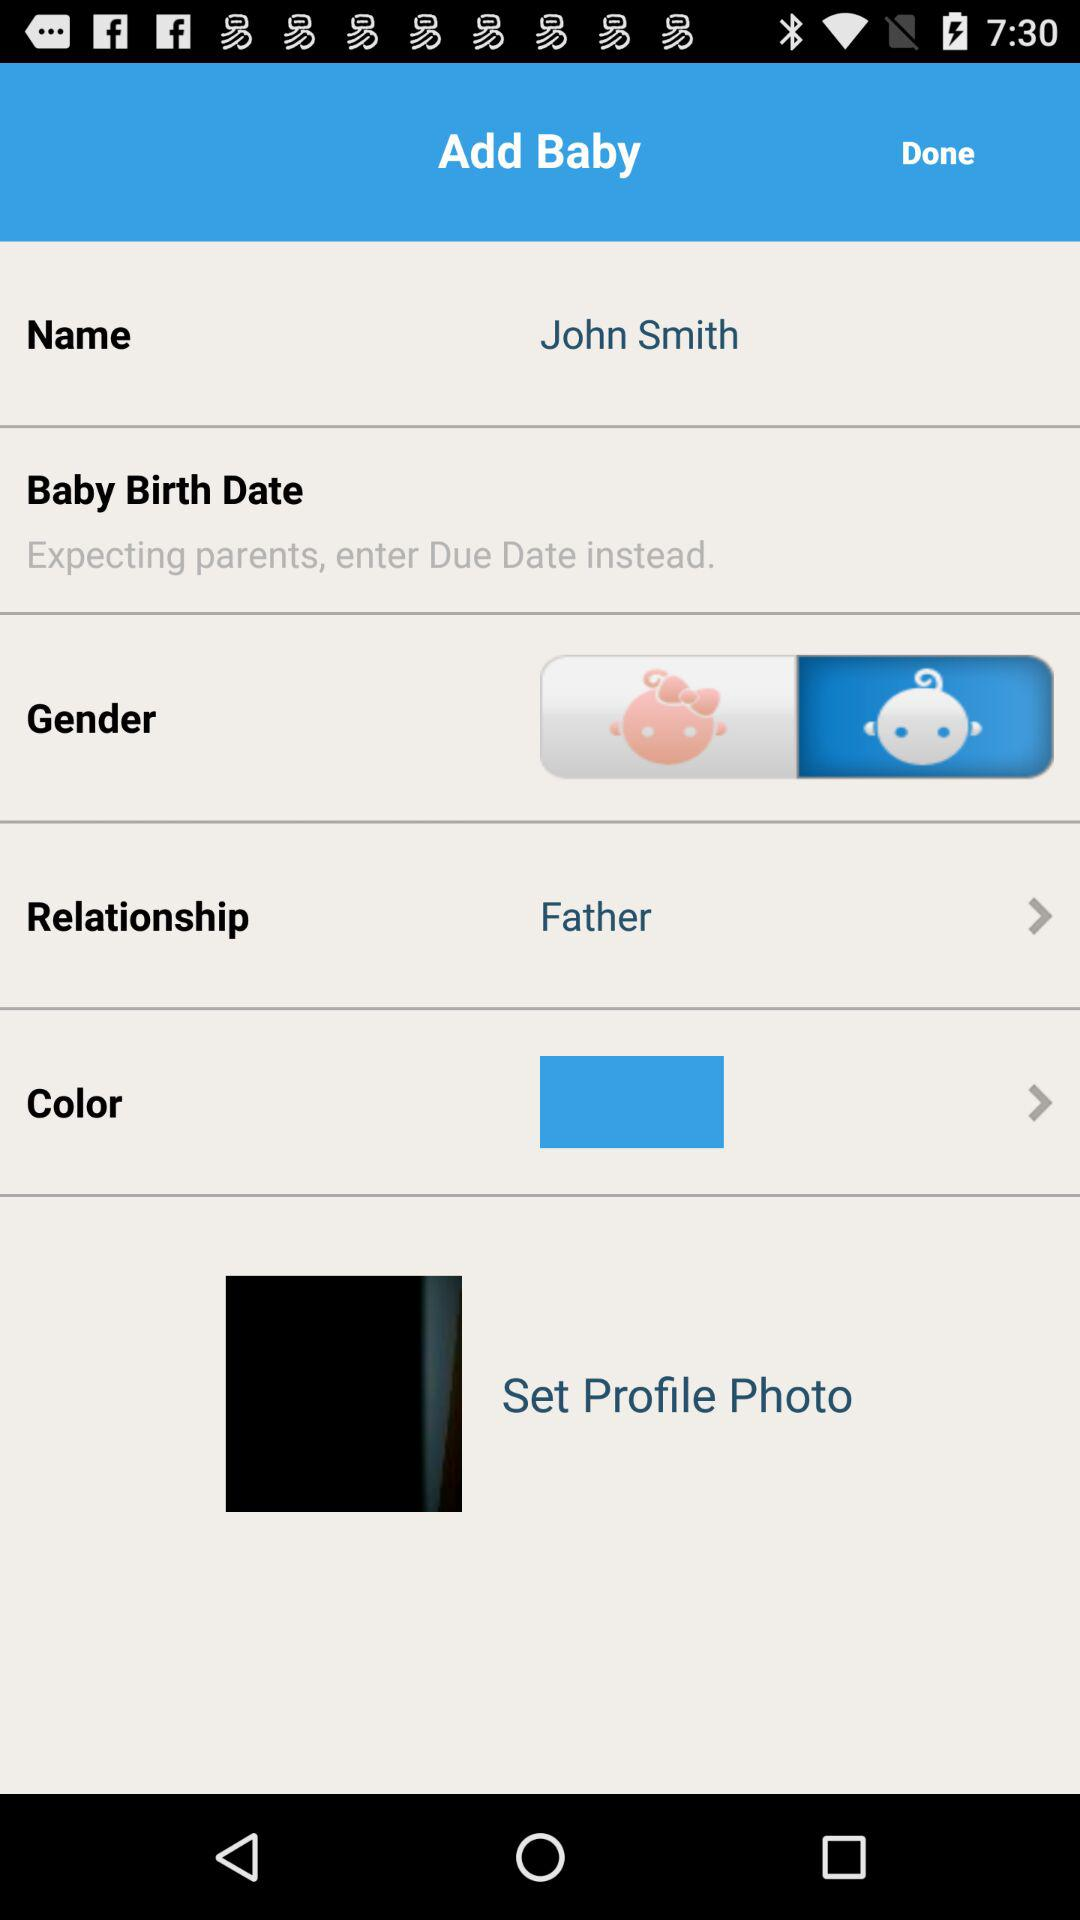How many text inputs are on the screen?
Answer the question using a single word or phrase. 2 